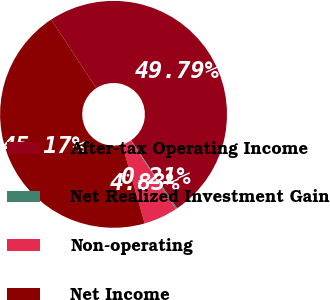Convert chart. <chart><loc_0><loc_0><loc_500><loc_500><pie_chart><fcel>After-tax Operating Income<fcel>Net Realized Investment Gain<fcel>Non-operating<fcel>Net Income<nl><fcel>49.79%<fcel>0.21%<fcel>4.83%<fcel>45.17%<nl></chart> 